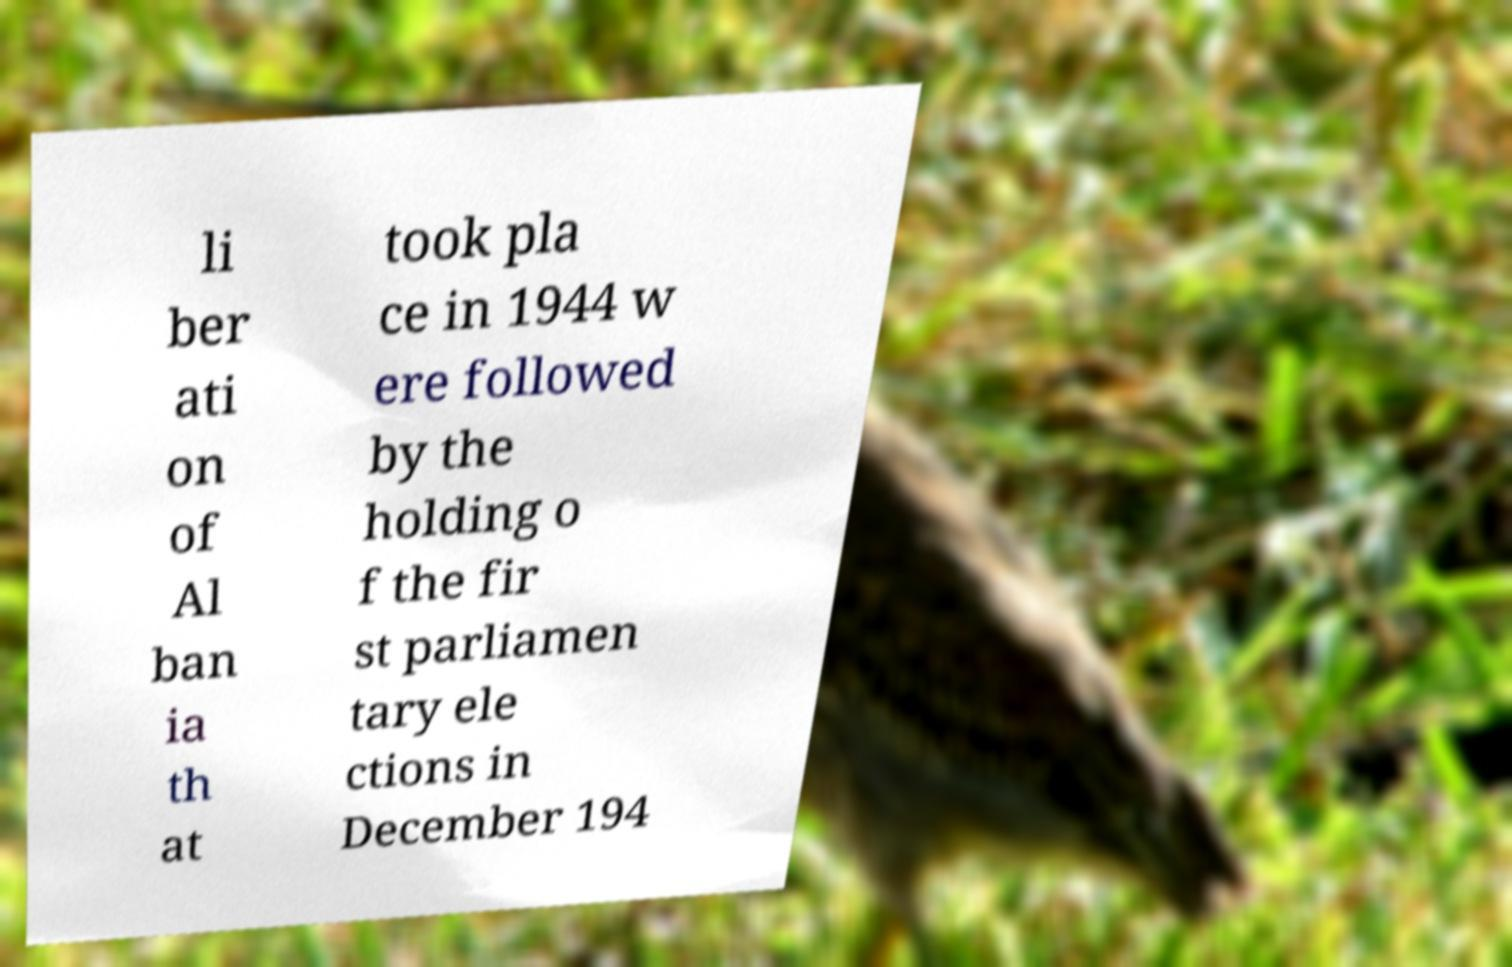Can you accurately transcribe the text from the provided image for me? li ber ati on of Al ban ia th at took pla ce in 1944 w ere followed by the holding o f the fir st parliamen tary ele ctions in December 194 